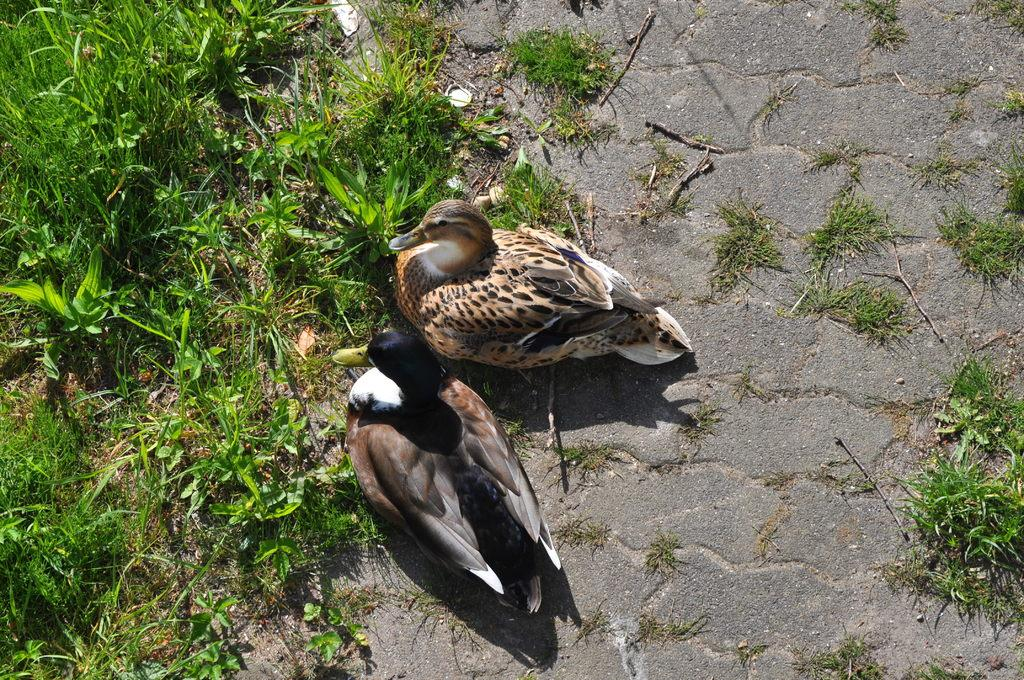What type of vegetation is present in the left corner of the image? There is grass and small plants in the left corner of the image. What animals can be seen in the foreground of the image? There are two birds in the foreground of the image. What type of pathway is visible at the bottom of the image? There is a road at the bottom of the image. What type of vegetation is present in the right corner of the image? There is grass in the right corner of the image. Can you see a giraffe driving a car on the road in the image? No, there are no giraffes or cars present in the image. Are there any mice visible in the image? No, there are no mice present in the image. 